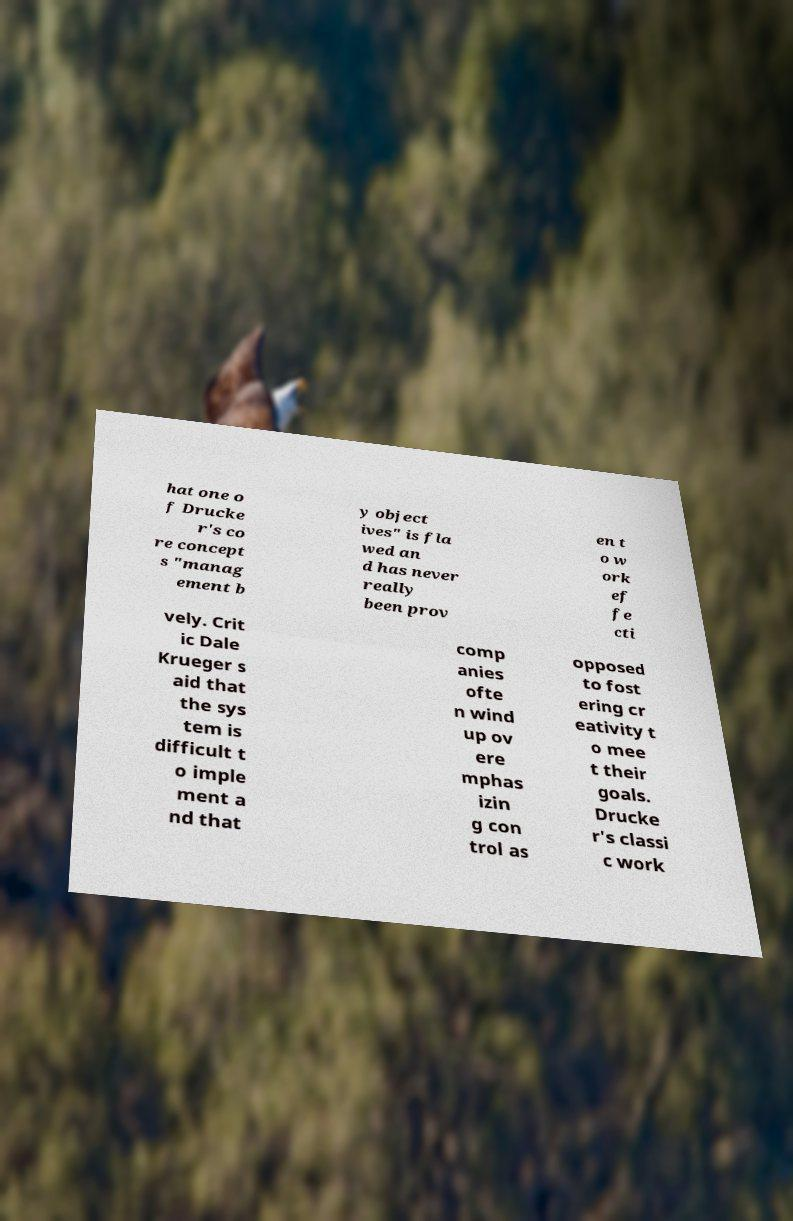Please read and relay the text visible in this image. What does it say? hat one o f Drucke r's co re concept s "manag ement b y object ives" is fla wed an d has never really been prov en t o w ork ef fe cti vely. Crit ic Dale Krueger s aid that the sys tem is difficult t o imple ment a nd that comp anies ofte n wind up ov ere mphas izin g con trol as opposed to fost ering cr eativity t o mee t their goals. Drucke r's classi c work 